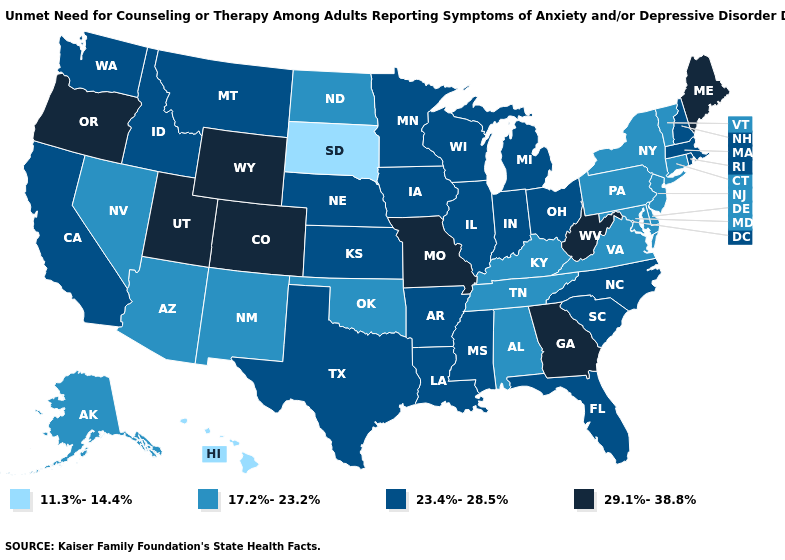What is the value of Ohio?
Keep it brief. 23.4%-28.5%. Does Hawaii have the lowest value in the USA?
Concise answer only. Yes. Is the legend a continuous bar?
Write a very short answer. No. Name the states that have a value in the range 11.3%-14.4%?
Concise answer only. Hawaii, South Dakota. Which states have the lowest value in the Northeast?
Quick response, please. Connecticut, New Jersey, New York, Pennsylvania, Vermont. Name the states that have a value in the range 11.3%-14.4%?
Answer briefly. Hawaii, South Dakota. Does Tennessee have a higher value than Hawaii?
Concise answer only. Yes. Among the states that border New Hampshire , which have the lowest value?
Quick response, please. Vermont. What is the highest value in the MidWest ?
Write a very short answer. 29.1%-38.8%. Which states have the lowest value in the South?
Short answer required. Alabama, Delaware, Kentucky, Maryland, Oklahoma, Tennessee, Virginia. Name the states that have a value in the range 17.2%-23.2%?
Keep it brief. Alabama, Alaska, Arizona, Connecticut, Delaware, Kentucky, Maryland, Nevada, New Jersey, New Mexico, New York, North Dakota, Oklahoma, Pennsylvania, Tennessee, Vermont, Virginia. Does Colorado have a higher value than Nebraska?
Concise answer only. Yes. What is the value of Texas?
Write a very short answer. 23.4%-28.5%. Does the map have missing data?
Answer briefly. No. Among the states that border New Hampshire , which have the lowest value?
Give a very brief answer. Vermont. 